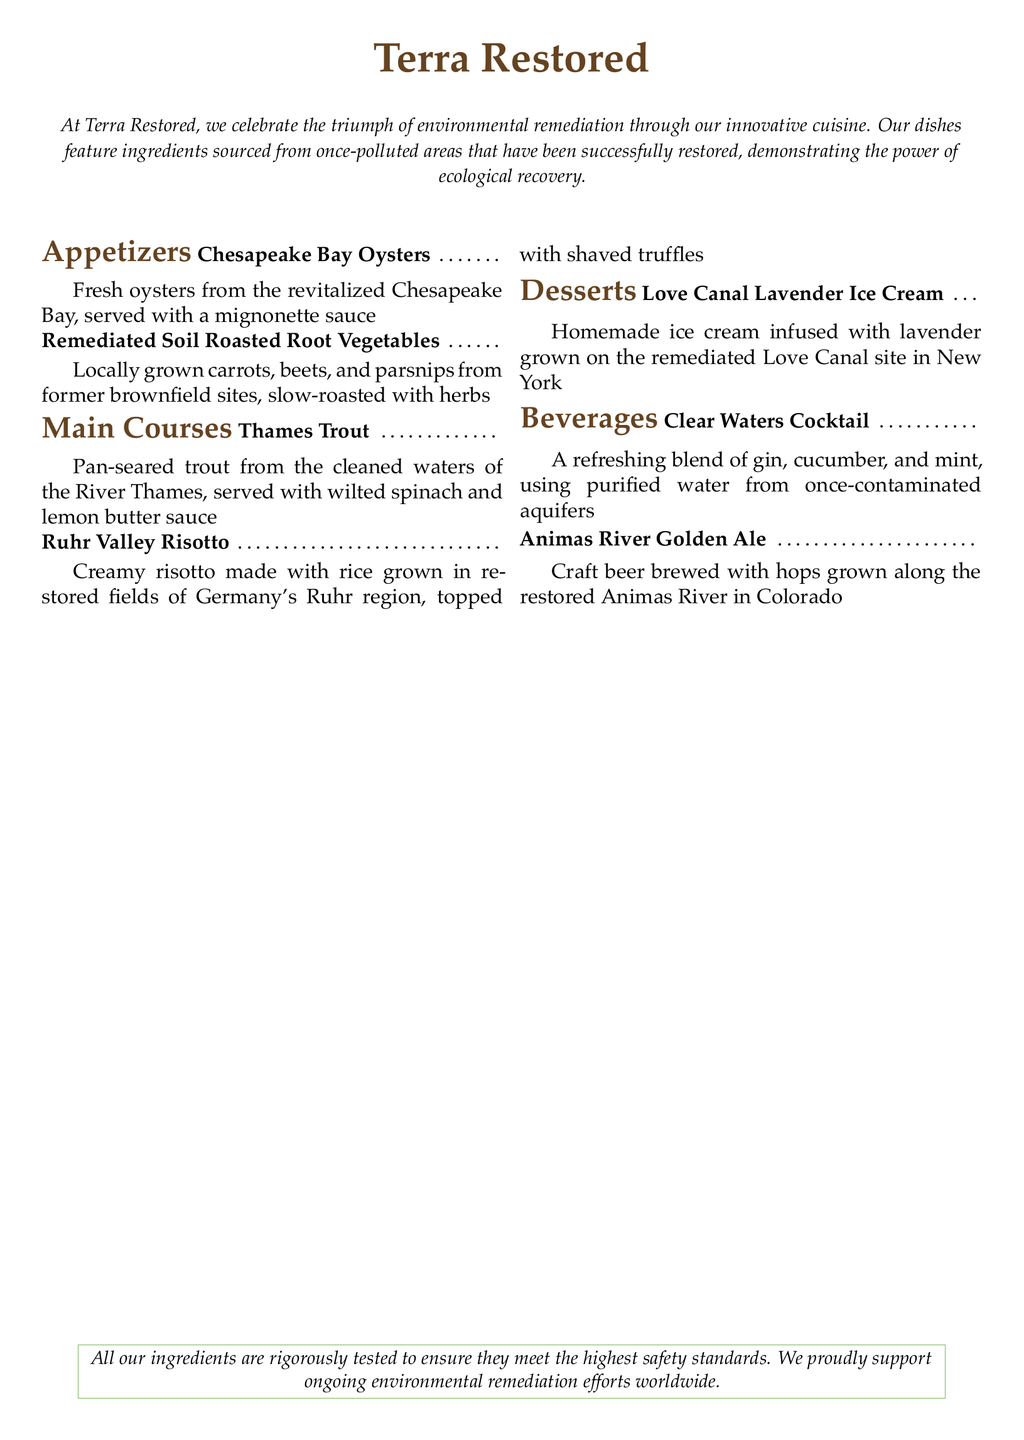What is the name of the restaurant? The name of the restaurant is prominently displayed at the top of the document.
Answer: Terra Restored What type of cuisine does Terra Restored offer? The menu describes their cuisine as innovative, celebrating environmental remediation through the use of certain ingredients.
Answer: Innovative cuisine Where are the oysters sourced from? The document specifies that the oysters are sourced from a revitalized area, detailing the location.
Answer: Chesapeake Bay What dish includes lavender? The menu lists a dessert that specifically mentions lavender as an ingredient.
Answer: Love Canal Lavender Ice Cream What is the main ingredient in the Ruhr Valley Risotto? The main ingredient for the risotto is specified in the dish description.
Answer: Rice What beverage is made with hops from a restored river? The menu mentions a specific beverage that uses hops grown in a particular area.
Answer: Animas River Golden Ale Which dish features root vegetables from former brownfield sites? The description of a specific appetizer indicates the source of the root vegetables.
Answer: Remediated Soil Roasted Root Vegetables What kind of cocktail is served at the restaurant? The menu describes a specific type of drink as a cocktail, including its main ingredients.
Answer: Clear Waters Cocktail How are the ingredients at Terra Restored tested? The document includes a statement about the safety standards for their ingredients.
Answer: Rigorously tested 